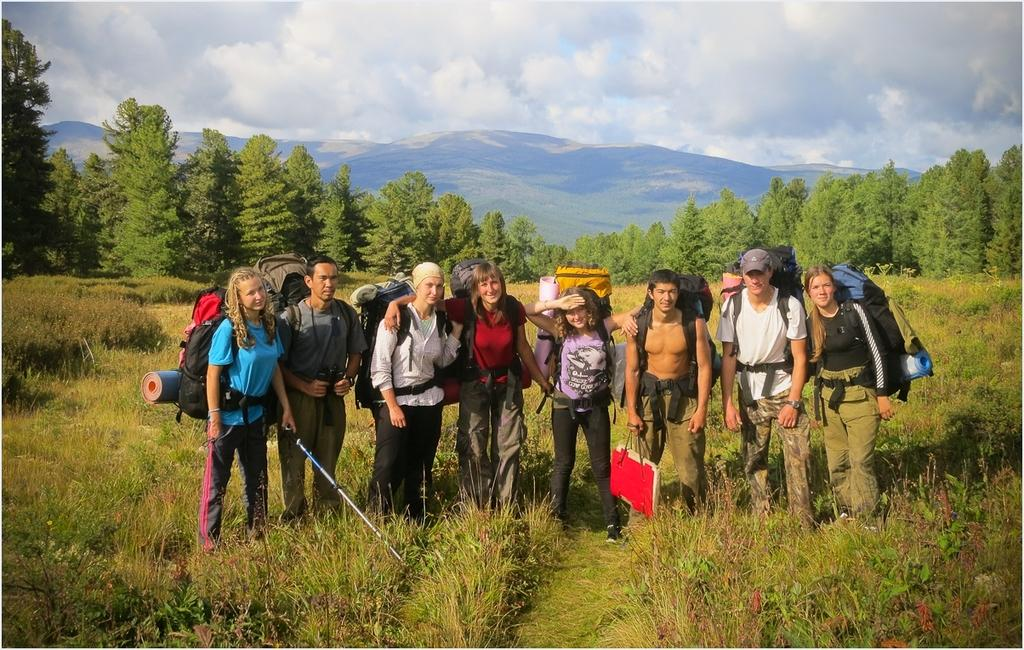What is the surface that the people are standing on in the image? The people are standing on the grass in the image. What are the people wearing that are visible in the image? The people are wearing bags in the image. What can be seen in the background of the image? There are trees, mountains, and the sky visible in the background of the image. What is the purpose of the stone in the image? There is no stone present in the image. How are the people transporting themselves in the image? The image does not show the people in motion or using any form of transport; they are simply standing on the grass. 